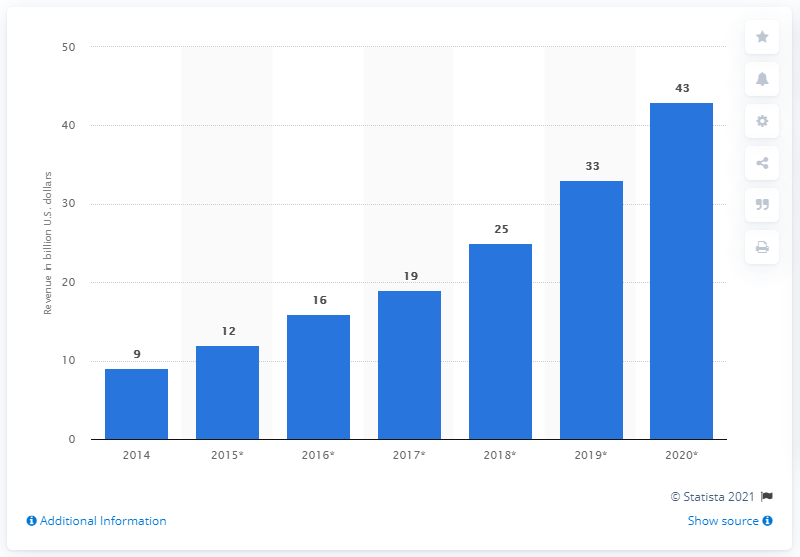Mention a couple of crucial points in this snapshot. The IoT semiconductor market was valued at approximately 9 billion dollars in 2014. 